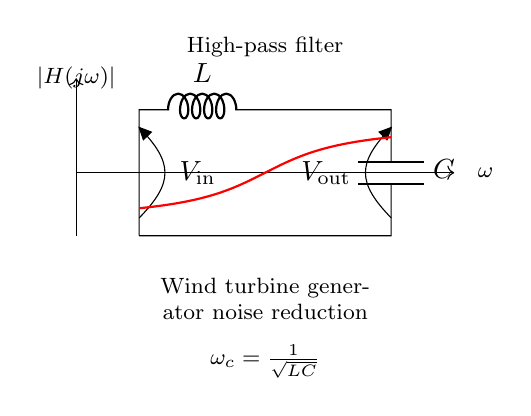What are the components in this high-pass filter circuit? The circuit diagram shows an inductor (L) and a capacitor (C) connected in series, forming a high-pass filter.
Answer: Inductor and capacitor What is the role of the capacitor in this circuit? The capacitor blocks low-frequency signals while allowing high-frequency signals to pass, contributing to the filter's functionality.
Answer: Block low frequencies What is the cutoff frequency formula provided in the diagram? The formula for the cutoff frequency is shown as omega_c equals one over the square root of LC, which indicates the frequency at which the filter begins to attenuate lower frequencies.
Answer: One over the square root of LC What is the direction of the input voltage indicated on the circuit? The input voltage is labeled as V_in and points from the junction at the top of the circuit (between L and C) towards the ground, indicating the input is applied at that node.
Answer: V_in How does this circuit reduce wind turbine generator noise? The circuit allows high-frequency components (like noise) to pass and attenuates low-frequency components associated with the noise generated by wind turbines, effectively reducing the perceived noise.
Answer: Attenuates low frequencies 